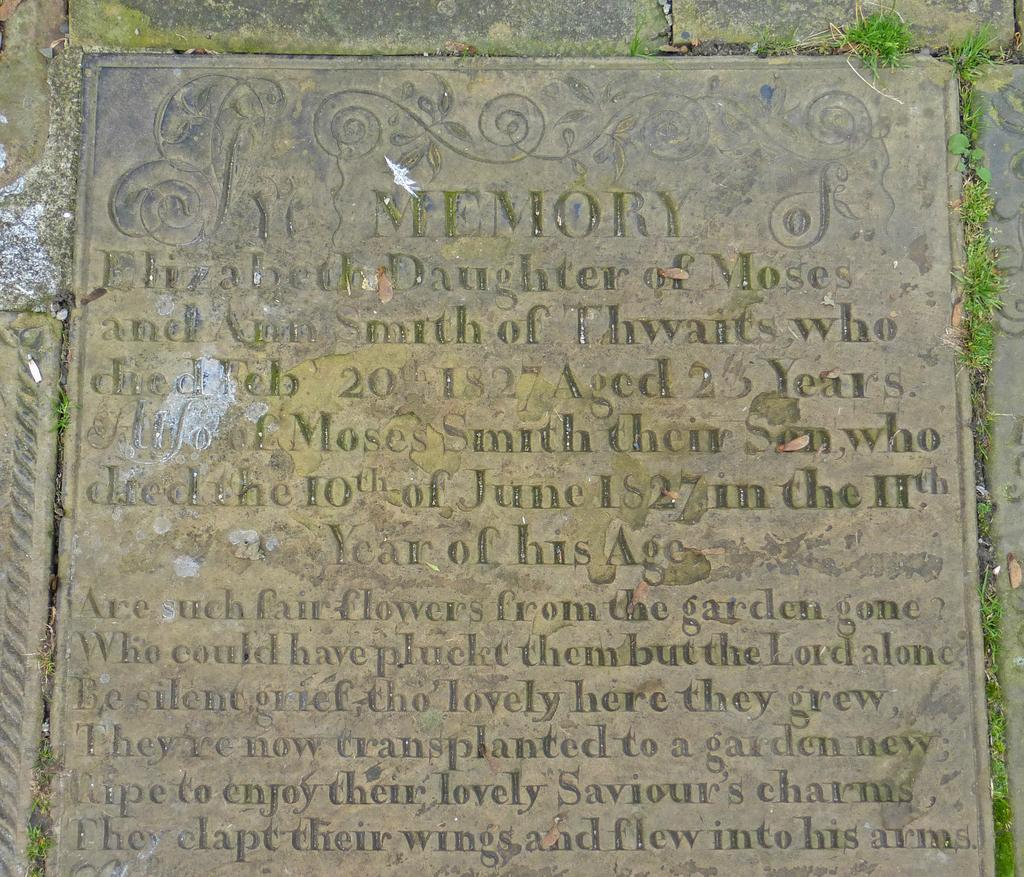What is the main object in the image? There is a headstone in the image. What can be seen on the headstone? There is writing on the headstone. Can you see a giraffe standing near the headstone in the image? No, there is no giraffe present in the image. Is the bag being pulled by someone in the image? There is no bag or anyone pulling it in the image. 